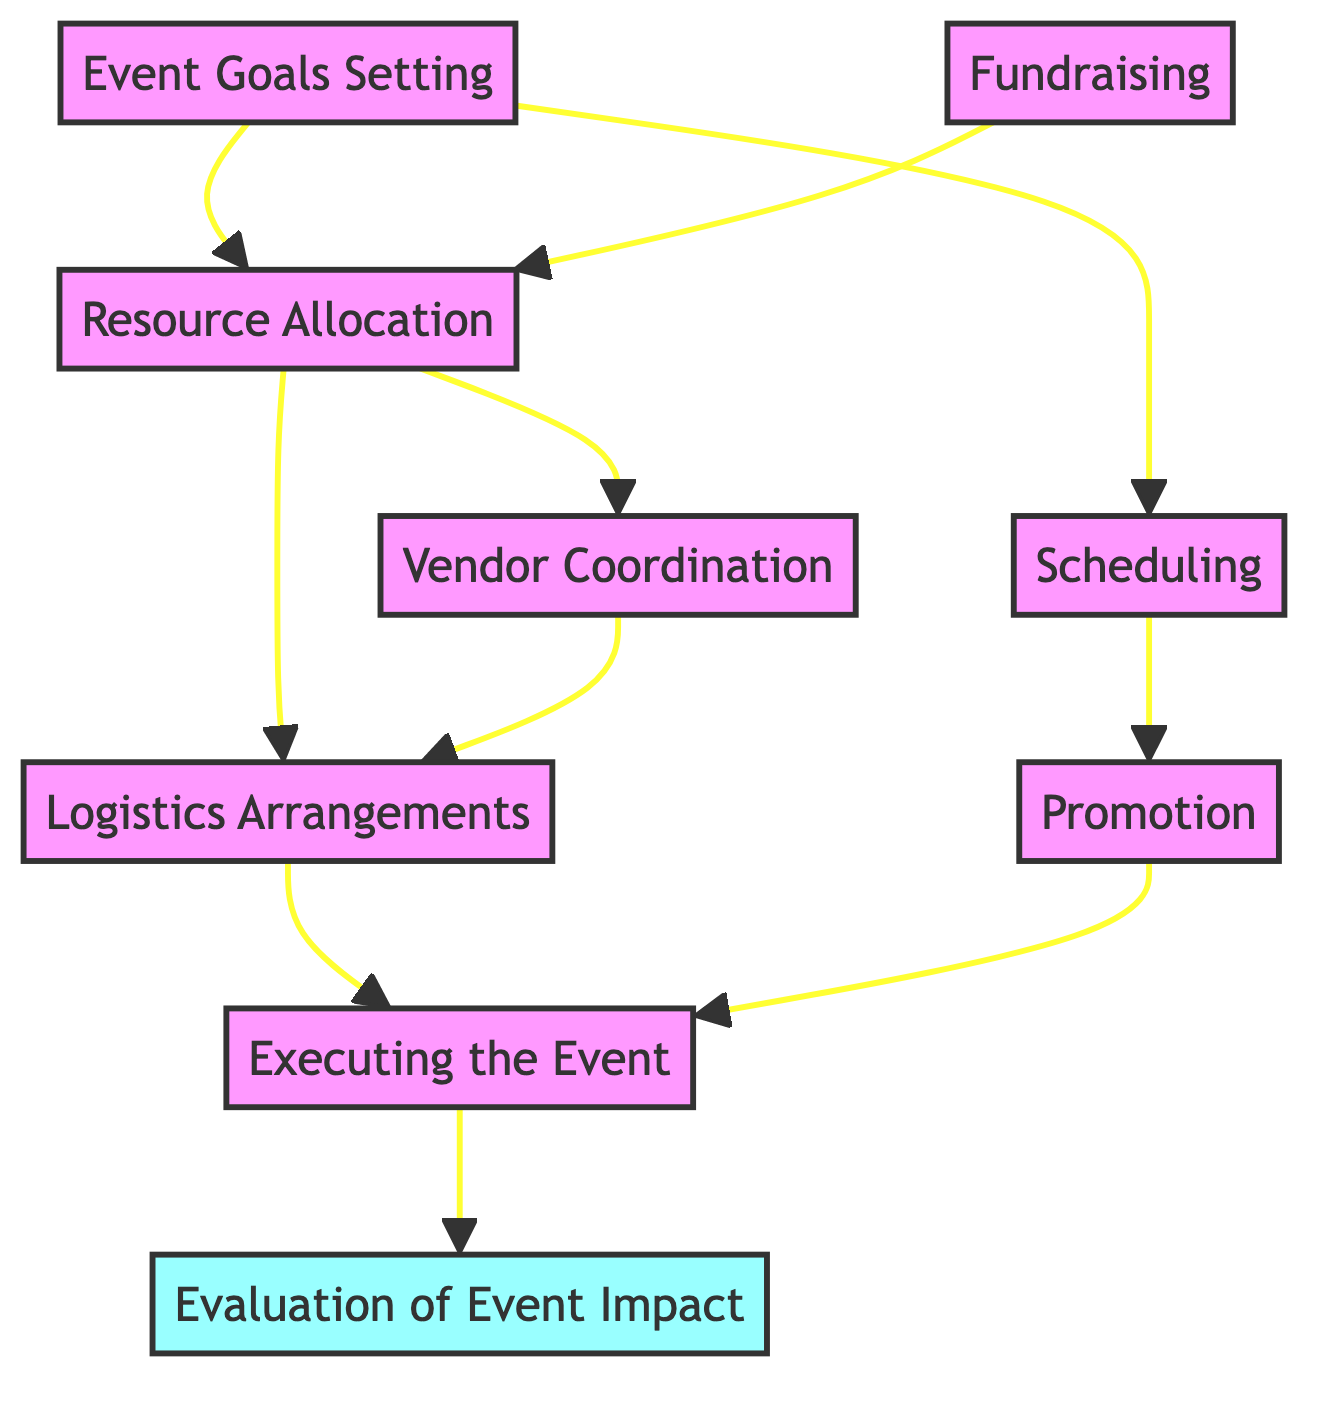What is the final step in the event planning process? The flowchart indicates that the final step is "Evaluation of Event Impact," which is connected to "Executing the Event." Therefore, it is the last activity that occurs after the event takes place.
Answer: Evaluation of Event Impact How many nodes are in the diagram? By counting each labeled step in the flowchart, we see there are 9 distinct nodes: Event Goals Setting, Fundraising, Resource Allocation, Vendor Coordination, Scheduling, Logistics Arrangements, Promotion, Executing the Event, and Evaluation of Event Impact.
Answer: 9 Which node comes before 'Executing the Event'? Looking at the connections outlined in the diagram, both "Promotion" and "Logistics Arrangements" lead to "Executing the Event." They are the nodes that directly precede it in the process.
Answer: Promotion, Logistics Arrangements What are the two nodes that connect to 'Resource Allocation'? The diagram shows that both "Fundraising" and "Logistics Arrangements" connect to "Resource Allocation." This means they are important steps that lead to the allocation of resources needed for the event.
Answer: Fundraising, Logistics Arrangements Which node is responsible for setting the date and time of the event? The diagram shows "Scheduling" as responsible for determining the date and time of the event, indicating it plays a critical role in event planning.
Answer: Scheduling What is the relationship between 'Scheduling' and 'Event Goals Setting'? The flowchart shows that "Event Goals Setting" is directly connected to "Scheduling." This indicates that setting goals precedes the scheduling process, as the goals likely influence when the event can take place.
Answer: Directly connected Which node requires feedback for evaluation? According to the diagram, the "Evaluation of Event Impact" node is responsible for collecting feedback to assess the event's success. This node serves to gather insights post-event.
Answer: Evaluation of Event Impact What must be arranged prior to 'Executing the Event'? The flowchart identifies that both "Promotion" and "Logistics Arrangements" must be completed before "Executing the Event," showing the importance of these preparations for a successful execution.
Answer: Promotion, Logistics Arrangements What comes after 'Executing the Event'? The process indicates that "Evaluation of Event Impact" follows "Executing the Event," meaning the assessment phase occurs right after the event takes place.
Answer: Evaluation of Event Impact 